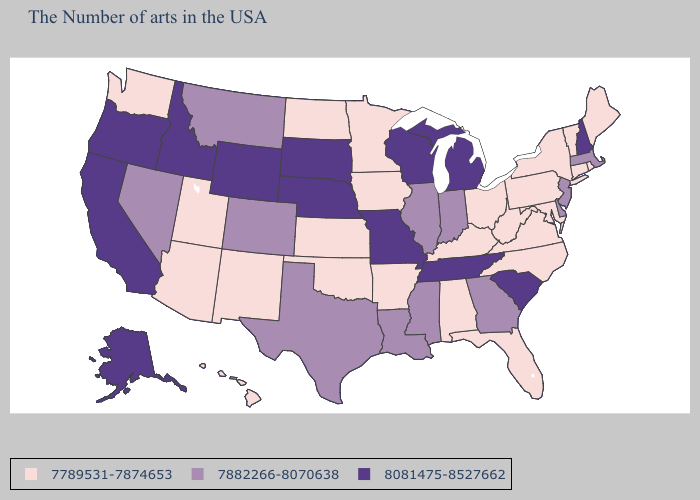What is the lowest value in the USA?
Short answer required. 7789531-7874653. Does Virginia have the same value as Montana?
Quick response, please. No. Does Connecticut have a higher value than Ohio?
Keep it brief. No. What is the value of Alabama?
Give a very brief answer. 7789531-7874653. What is the lowest value in the Northeast?
Answer briefly. 7789531-7874653. What is the lowest value in the USA?
Quick response, please. 7789531-7874653. Which states have the lowest value in the USA?
Keep it brief. Maine, Rhode Island, Vermont, Connecticut, New York, Maryland, Pennsylvania, Virginia, North Carolina, West Virginia, Ohio, Florida, Kentucky, Alabama, Arkansas, Minnesota, Iowa, Kansas, Oklahoma, North Dakota, New Mexico, Utah, Arizona, Washington, Hawaii. Which states have the highest value in the USA?
Answer briefly. New Hampshire, South Carolina, Michigan, Tennessee, Wisconsin, Missouri, Nebraska, South Dakota, Wyoming, Idaho, California, Oregon, Alaska. What is the lowest value in states that border North Carolina?
Concise answer only. 7789531-7874653. Does South Carolina have the highest value in the South?
Quick response, please. Yes. What is the lowest value in the USA?
Answer briefly. 7789531-7874653. What is the lowest value in the West?
Give a very brief answer. 7789531-7874653. Which states have the lowest value in the West?
Quick response, please. New Mexico, Utah, Arizona, Washington, Hawaii. What is the lowest value in the USA?
Be succinct. 7789531-7874653. 